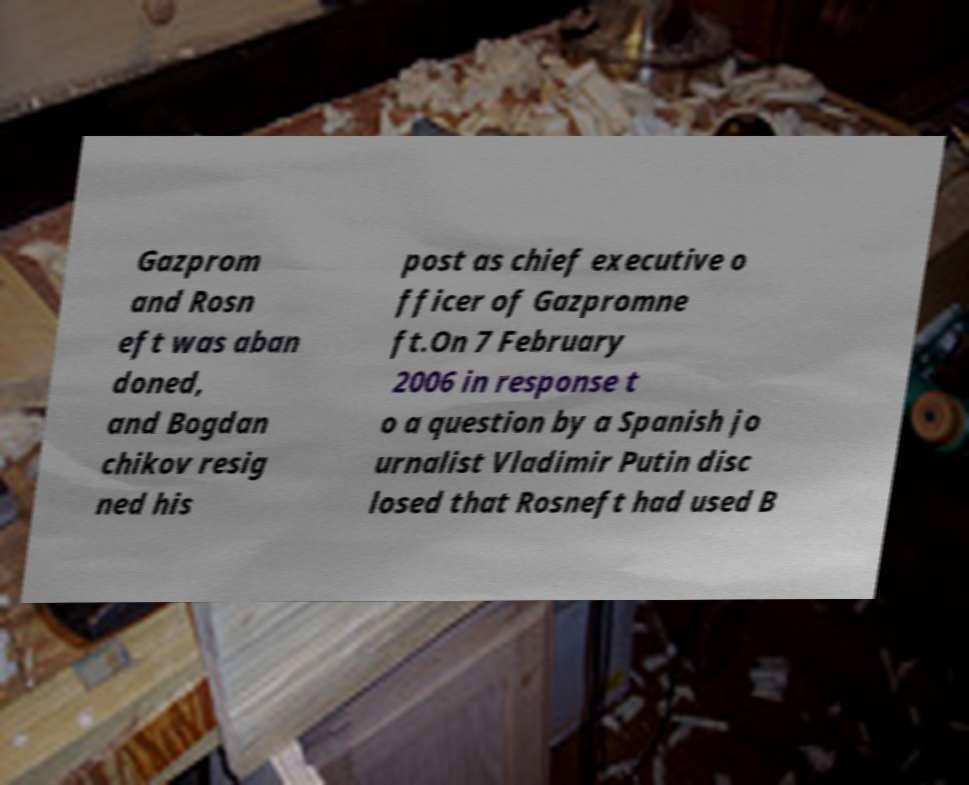Please identify and transcribe the text found in this image. Gazprom and Rosn eft was aban doned, and Bogdan chikov resig ned his post as chief executive o fficer of Gazpromne ft.On 7 February 2006 in response t o a question by a Spanish jo urnalist Vladimir Putin disc losed that Rosneft had used B 